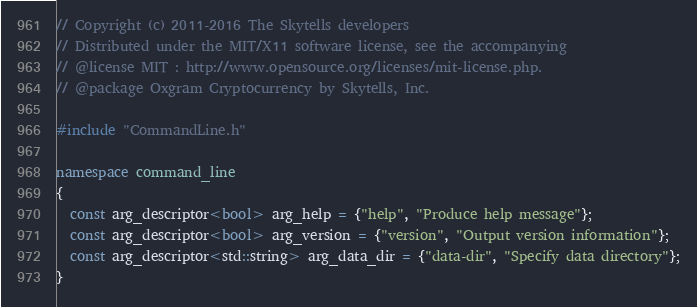<code> <loc_0><loc_0><loc_500><loc_500><_C++_>// Copyright (c) 2011-2016 The Skytells developers
// Distributed under the MIT/X11 software license, see the accompanying
// @license MIT : http://www.opensource.org/licenses/mit-license.php.
// @package Oxgram Cryptocurrency by Skytells, Inc.

#include "CommandLine.h"

namespace command_line
{
  const arg_descriptor<bool> arg_help = {"help", "Produce help message"};
  const arg_descriptor<bool> arg_version = {"version", "Output version information"};
  const arg_descriptor<std::string> arg_data_dir = {"data-dir", "Specify data directory"};
}
</code> 